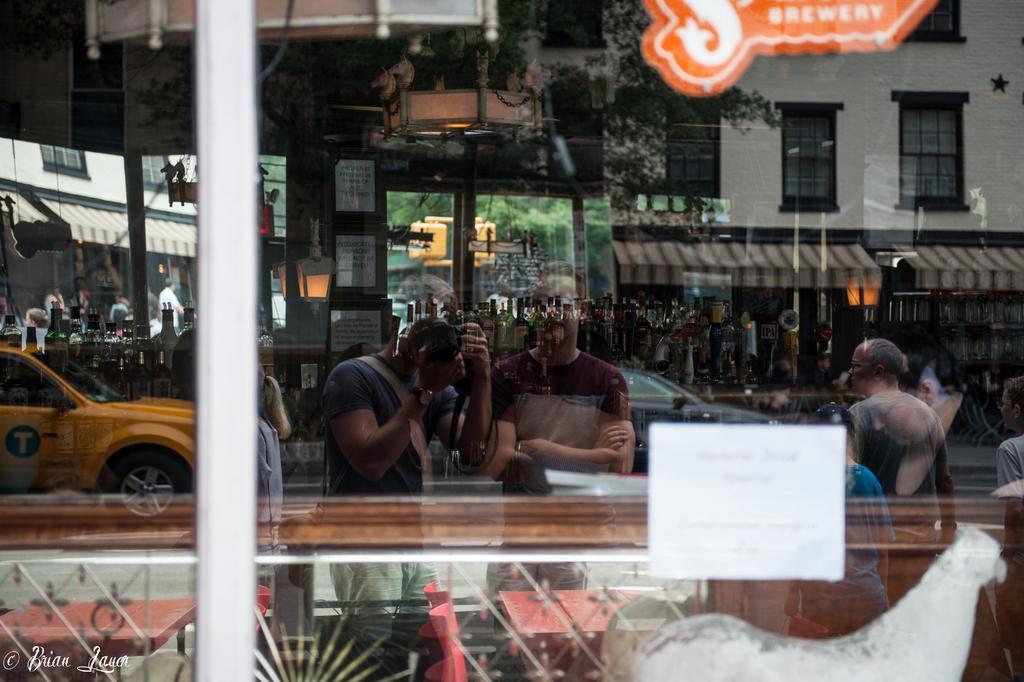Please provide a concise description of this image. This is glass. From the glass we can see vehicles, persons, frames, trees, and buildings. 